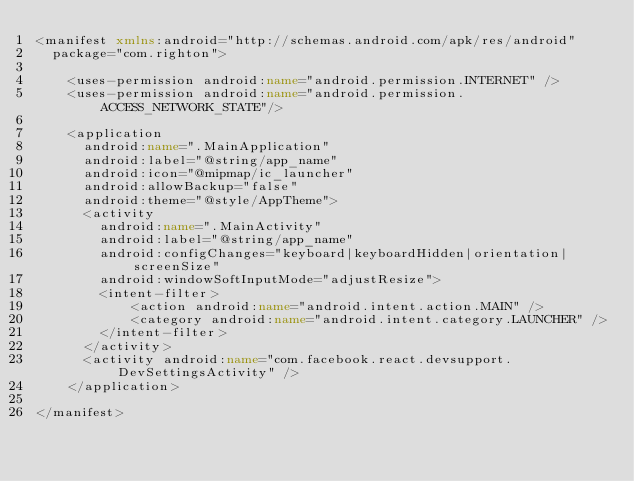<code> <loc_0><loc_0><loc_500><loc_500><_XML_><manifest xmlns:android="http://schemas.android.com/apk/res/android"
  package="com.righton">

    <uses-permission android:name="android.permission.INTERNET" />
    <uses-permission android:name="android.permission.ACCESS_NETWORK_STATE"/>

    <application
      android:name=".MainApplication"
      android:label="@string/app_name"
      android:icon="@mipmap/ic_launcher"
      android:allowBackup="false"
      android:theme="@style/AppTheme">
      <activity
        android:name=".MainActivity"
        android:label="@string/app_name"
        android:configChanges="keyboard|keyboardHidden|orientation|screenSize"
        android:windowSoftInputMode="adjustResize">
        <intent-filter>
            <action android:name="android.intent.action.MAIN" />
            <category android:name="android.intent.category.LAUNCHER" />
        </intent-filter>
      </activity>
      <activity android:name="com.facebook.react.devsupport.DevSettingsActivity" />
    </application>

</manifest>
</code> 